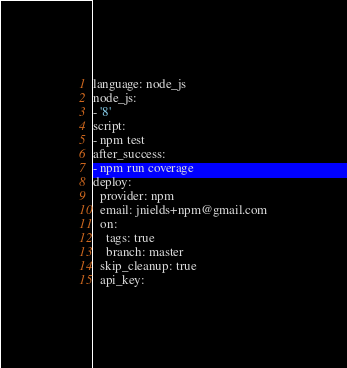<code> <loc_0><loc_0><loc_500><loc_500><_YAML_>language: node_js
node_js:
- '8'
script:
- npm test
after_success:
- npm run coverage
deploy:
  provider: npm
  email: jnields+npm@gmail.com
  on:
    tags: true
    branch: master
  skip_cleanup: true
  api_key:</code> 